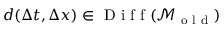<formula> <loc_0><loc_0><loc_500><loc_500>d ( \Delta t , \Delta x ) \in D i f f ( \mathcal { M } _ { o l d } )</formula> 